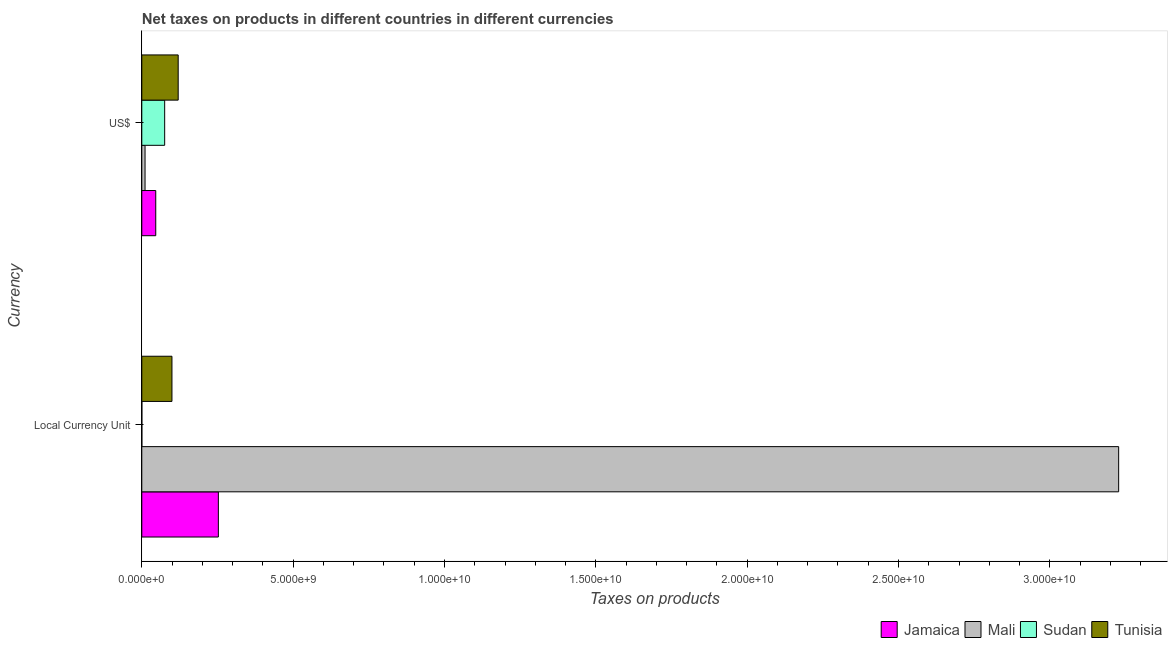How many groups of bars are there?
Make the answer very short. 2. Are the number of bars on each tick of the Y-axis equal?
Make the answer very short. Yes. What is the label of the 1st group of bars from the top?
Give a very brief answer. US$. What is the net taxes in constant 2005 us$ in Tunisia?
Make the answer very short. 9.96e+08. Across all countries, what is the maximum net taxes in us$?
Provide a short and direct response. 1.20e+09. Across all countries, what is the minimum net taxes in us$?
Offer a terse response. 1.07e+08. In which country was the net taxes in constant 2005 us$ maximum?
Provide a short and direct response. Mali. In which country was the net taxes in constant 2005 us$ minimum?
Your response must be concise. Sudan. What is the total net taxes in us$ in the graph?
Give a very brief answer. 2.53e+09. What is the difference between the net taxes in us$ in Mali and that in Jamaica?
Offer a very short reply. -3.54e+08. What is the difference between the net taxes in us$ in Jamaica and the net taxes in constant 2005 us$ in Sudan?
Make the answer very short. 4.60e+08. What is the average net taxes in constant 2005 us$ per country?
Give a very brief answer. 8.95e+09. What is the difference between the net taxes in us$ and net taxes in constant 2005 us$ in Mali?
Your response must be concise. -3.22e+1. In how many countries, is the net taxes in constant 2005 us$ greater than 6000000000 units?
Give a very brief answer. 1. What is the ratio of the net taxes in constant 2005 us$ in Jamaica to that in Tunisia?
Provide a short and direct response. 2.54. Is the net taxes in us$ in Mali less than that in Tunisia?
Offer a very short reply. Yes. What does the 3rd bar from the top in Local Currency Unit represents?
Give a very brief answer. Mali. What does the 1st bar from the bottom in Local Currency Unit represents?
Make the answer very short. Jamaica. How many countries are there in the graph?
Provide a succinct answer. 4. What is the difference between two consecutive major ticks on the X-axis?
Provide a succinct answer. 5.00e+09. Does the graph contain grids?
Keep it short and to the point. No. How are the legend labels stacked?
Ensure brevity in your answer.  Horizontal. What is the title of the graph?
Make the answer very short. Net taxes on products in different countries in different currencies. What is the label or title of the X-axis?
Make the answer very short. Taxes on products. What is the label or title of the Y-axis?
Make the answer very short. Currency. What is the Taxes on products in Jamaica in Local Currency Unit?
Your response must be concise. 2.53e+09. What is the Taxes on products in Mali in Local Currency Unit?
Your answer should be very brief. 3.23e+1. What is the Taxes on products of Sudan in Local Currency Unit?
Your answer should be very brief. 1.33e+06. What is the Taxes on products of Tunisia in Local Currency Unit?
Offer a very short reply. 9.96e+08. What is the Taxes on products of Jamaica in US$?
Give a very brief answer. 4.61e+08. What is the Taxes on products of Mali in US$?
Provide a succinct answer. 1.07e+08. What is the Taxes on products in Sudan in US$?
Your response must be concise. 7.56e+08. What is the Taxes on products in Tunisia in US$?
Offer a terse response. 1.20e+09. Across all Currency, what is the maximum Taxes on products in Jamaica?
Provide a short and direct response. 2.53e+09. Across all Currency, what is the maximum Taxes on products in Mali?
Provide a short and direct response. 3.23e+1. Across all Currency, what is the maximum Taxes on products in Sudan?
Provide a short and direct response. 7.56e+08. Across all Currency, what is the maximum Taxes on products of Tunisia?
Your answer should be very brief. 1.20e+09. Across all Currency, what is the minimum Taxes on products of Jamaica?
Provide a succinct answer. 4.61e+08. Across all Currency, what is the minimum Taxes on products of Mali?
Provide a succinct answer. 1.07e+08. Across all Currency, what is the minimum Taxes on products in Sudan?
Offer a very short reply. 1.33e+06. Across all Currency, what is the minimum Taxes on products in Tunisia?
Provide a succinct answer. 9.96e+08. What is the total Taxes on products of Jamaica in the graph?
Your response must be concise. 2.99e+09. What is the total Taxes on products in Mali in the graph?
Provide a short and direct response. 3.24e+1. What is the total Taxes on products in Sudan in the graph?
Your answer should be compact. 7.57e+08. What is the total Taxes on products of Tunisia in the graph?
Provide a succinct answer. 2.20e+09. What is the difference between the Taxes on products in Jamaica in Local Currency Unit and that in US$?
Make the answer very short. 2.07e+09. What is the difference between the Taxes on products in Mali in Local Currency Unit and that in US$?
Your response must be concise. 3.22e+1. What is the difference between the Taxes on products in Sudan in Local Currency Unit and that in US$?
Keep it short and to the point. -7.54e+08. What is the difference between the Taxes on products of Tunisia in Local Currency Unit and that in US$?
Provide a short and direct response. -2.06e+08. What is the difference between the Taxes on products of Jamaica in Local Currency Unit and the Taxes on products of Mali in US$?
Your answer should be compact. 2.42e+09. What is the difference between the Taxes on products of Jamaica in Local Currency Unit and the Taxes on products of Sudan in US$?
Your response must be concise. 1.77e+09. What is the difference between the Taxes on products of Jamaica in Local Currency Unit and the Taxes on products of Tunisia in US$?
Make the answer very short. 1.33e+09. What is the difference between the Taxes on products of Mali in Local Currency Unit and the Taxes on products of Sudan in US$?
Offer a terse response. 3.15e+1. What is the difference between the Taxes on products of Mali in Local Currency Unit and the Taxes on products of Tunisia in US$?
Offer a terse response. 3.11e+1. What is the difference between the Taxes on products of Sudan in Local Currency Unit and the Taxes on products of Tunisia in US$?
Provide a short and direct response. -1.20e+09. What is the average Taxes on products of Jamaica per Currency?
Your answer should be compact. 1.50e+09. What is the average Taxes on products of Mali per Currency?
Give a very brief answer. 1.62e+1. What is the average Taxes on products in Sudan per Currency?
Offer a terse response. 3.79e+08. What is the average Taxes on products of Tunisia per Currency?
Your answer should be compact. 1.10e+09. What is the difference between the Taxes on products of Jamaica and Taxes on products of Mali in Local Currency Unit?
Give a very brief answer. -2.97e+1. What is the difference between the Taxes on products of Jamaica and Taxes on products of Sudan in Local Currency Unit?
Your answer should be very brief. 2.53e+09. What is the difference between the Taxes on products of Jamaica and Taxes on products of Tunisia in Local Currency Unit?
Keep it short and to the point. 1.53e+09. What is the difference between the Taxes on products in Mali and Taxes on products in Sudan in Local Currency Unit?
Your response must be concise. 3.23e+1. What is the difference between the Taxes on products in Mali and Taxes on products in Tunisia in Local Currency Unit?
Ensure brevity in your answer.  3.13e+1. What is the difference between the Taxes on products of Sudan and Taxes on products of Tunisia in Local Currency Unit?
Offer a terse response. -9.95e+08. What is the difference between the Taxes on products of Jamaica and Taxes on products of Mali in US$?
Offer a very short reply. 3.54e+08. What is the difference between the Taxes on products of Jamaica and Taxes on products of Sudan in US$?
Offer a terse response. -2.95e+08. What is the difference between the Taxes on products in Jamaica and Taxes on products in Tunisia in US$?
Your answer should be compact. -7.41e+08. What is the difference between the Taxes on products of Mali and Taxes on products of Sudan in US$?
Ensure brevity in your answer.  -6.48e+08. What is the difference between the Taxes on products in Mali and Taxes on products in Tunisia in US$?
Provide a short and direct response. -1.10e+09. What is the difference between the Taxes on products in Sudan and Taxes on products in Tunisia in US$?
Give a very brief answer. -4.47e+08. What is the ratio of the Taxes on products of Jamaica in Local Currency Unit to that in US$?
Keep it short and to the point. 5.49. What is the ratio of the Taxes on products of Mali in Local Currency Unit to that in US$?
Ensure brevity in your answer.  300.54. What is the ratio of the Taxes on products in Sudan in Local Currency Unit to that in US$?
Make the answer very short. 0. What is the ratio of the Taxes on products of Tunisia in Local Currency Unit to that in US$?
Keep it short and to the point. 0.83. What is the difference between the highest and the second highest Taxes on products in Jamaica?
Provide a short and direct response. 2.07e+09. What is the difference between the highest and the second highest Taxes on products of Mali?
Offer a terse response. 3.22e+1. What is the difference between the highest and the second highest Taxes on products of Sudan?
Provide a short and direct response. 7.54e+08. What is the difference between the highest and the second highest Taxes on products in Tunisia?
Your response must be concise. 2.06e+08. What is the difference between the highest and the lowest Taxes on products in Jamaica?
Make the answer very short. 2.07e+09. What is the difference between the highest and the lowest Taxes on products in Mali?
Give a very brief answer. 3.22e+1. What is the difference between the highest and the lowest Taxes on products of Sudan?
Ensure brevity in your answer.  7.54e+08. What is the difference between the highest and the lowest Taxes on products of Tunisia?
Your answer should be compact. 2.06e+08. 